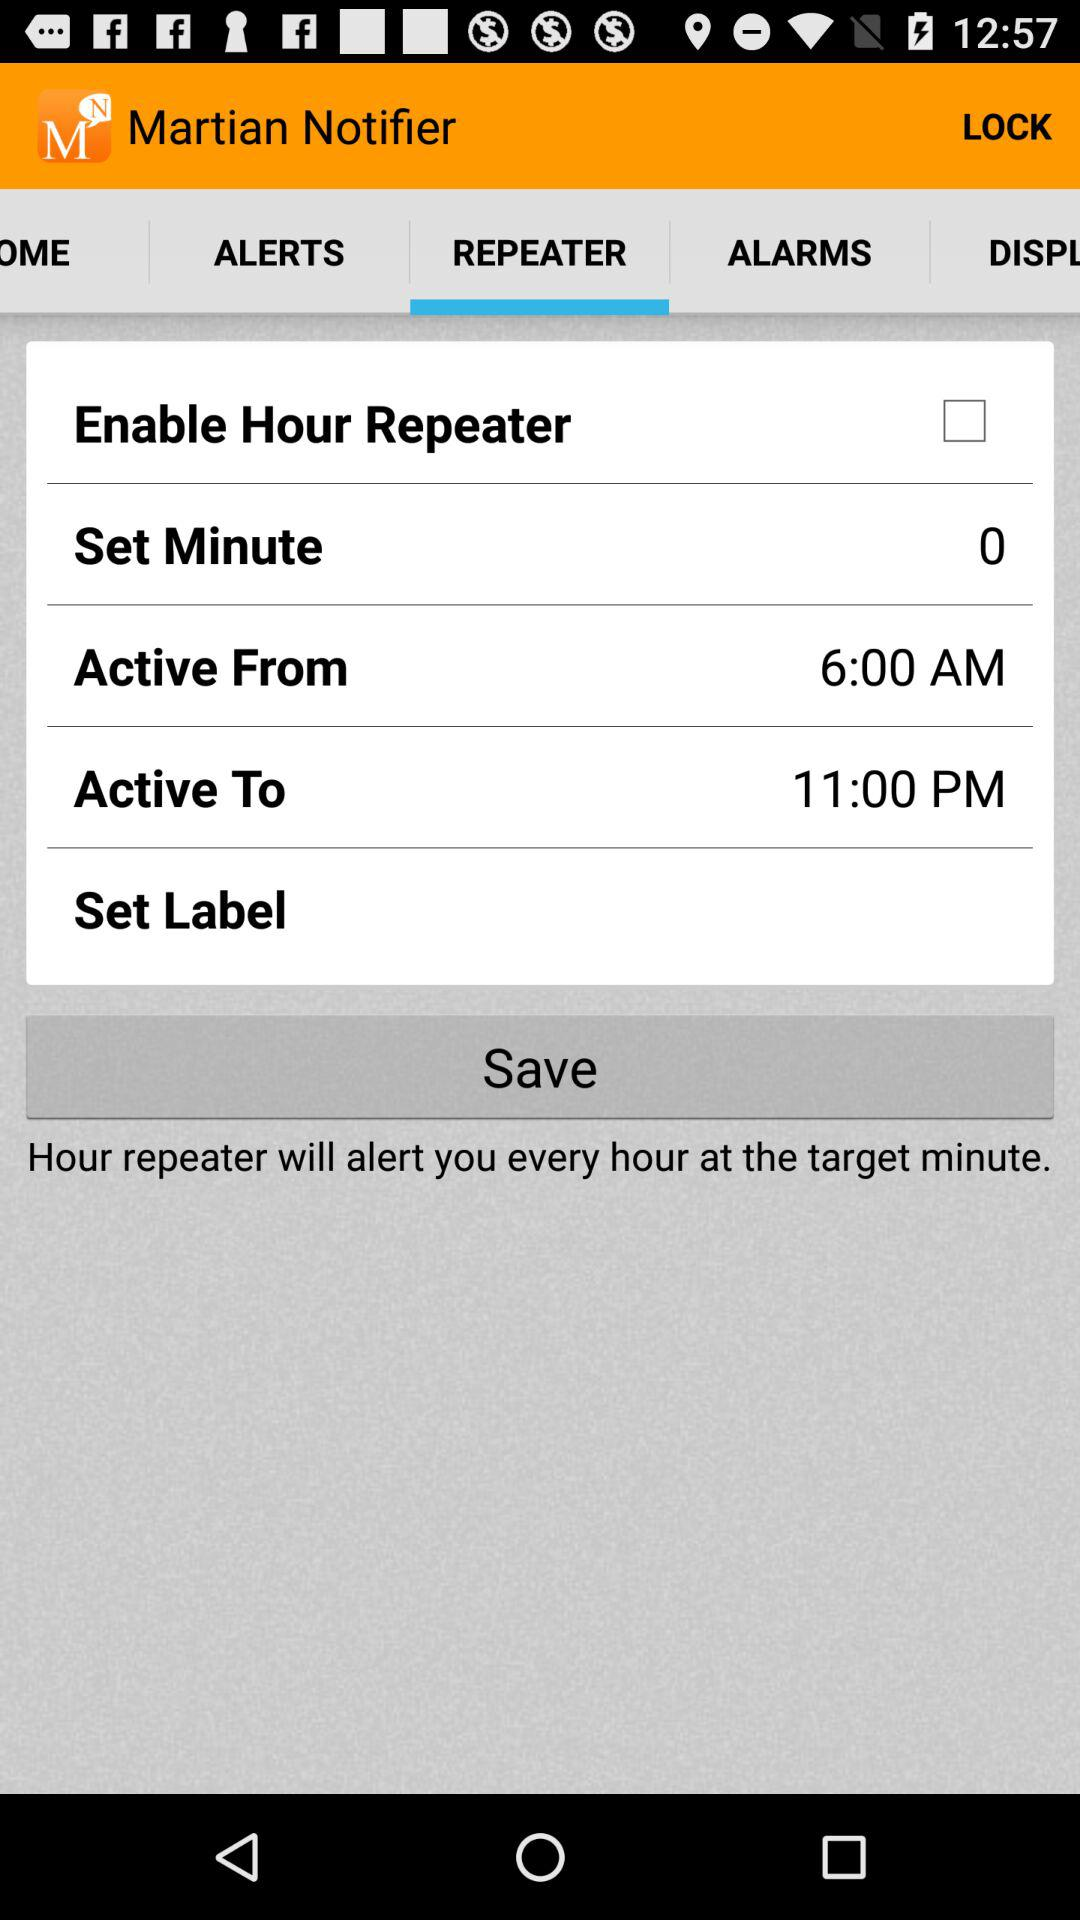What tab is selected? The selected tab is "REPEATER". 